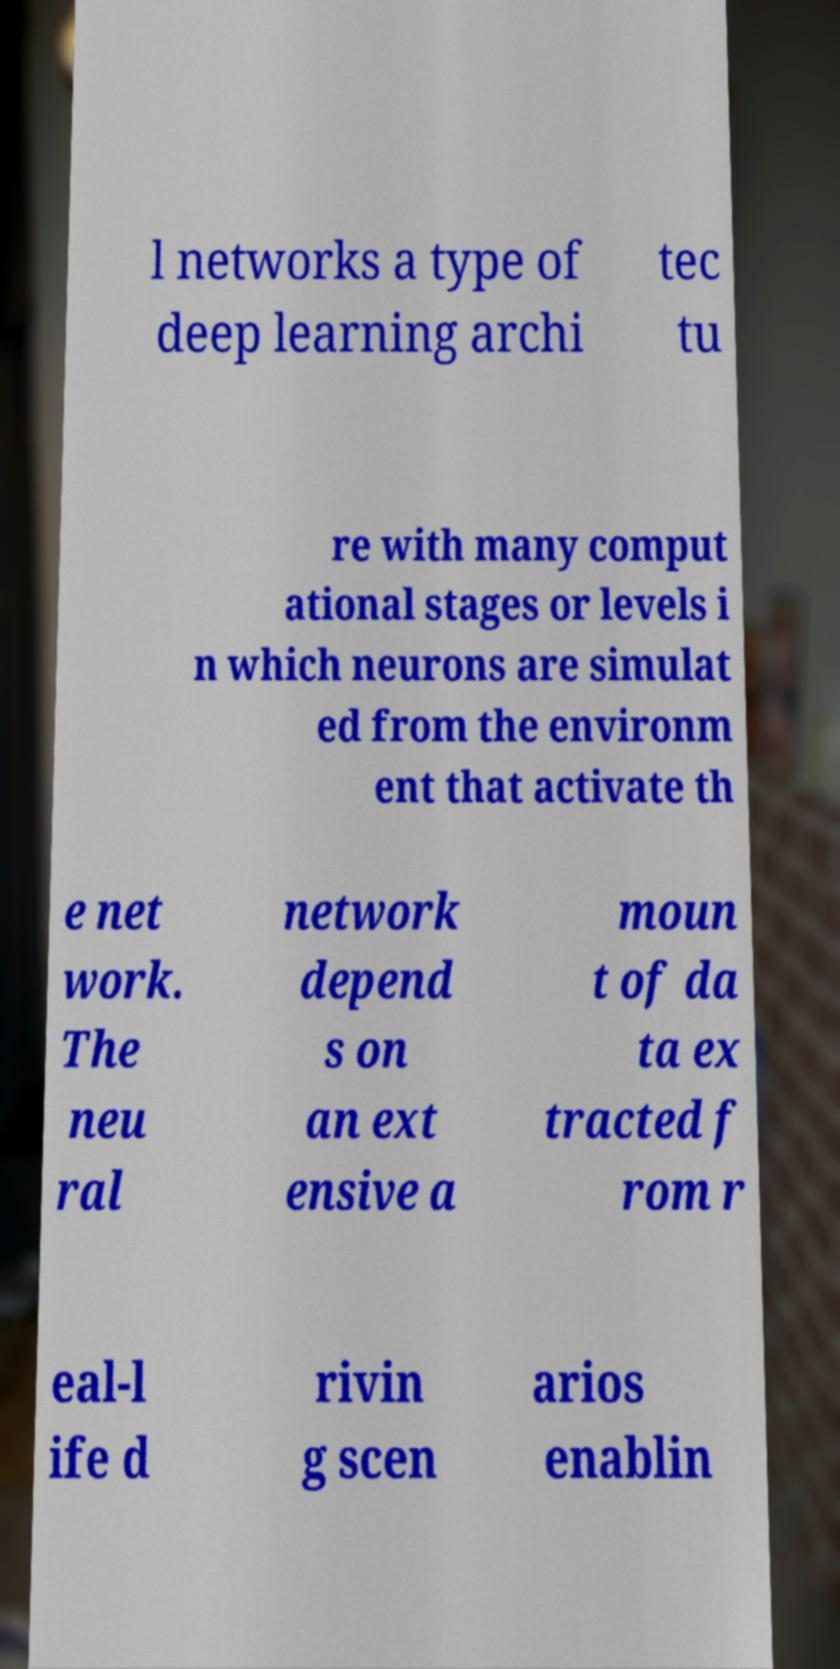Please identify and transcribe the text found in this image. l networks a type of deep learning archi tec tu re with many comput ational stages or levels i n which neurons are simulat ed from the environm ent that activate th e net work. The neu ral network depend s on an ext ensive a moun t of da ta ex tracted f rom r eal-l ife d rivin g scen arios enablin 